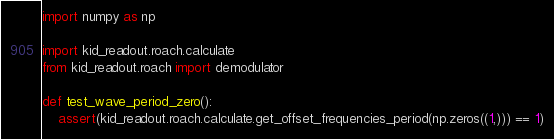Convert code to text. <code><loc_0><loc_0><loc_500><loc_500><_Python_>import numpy as np

import kid_readout.roach.calculate
from kid_readout.roach import demodulator

def test_wave_period_zero():
    assert(kid_readout.roach.calculate.get_offset_frequencies_period(np.zeros((1,))) == 1)</code> 